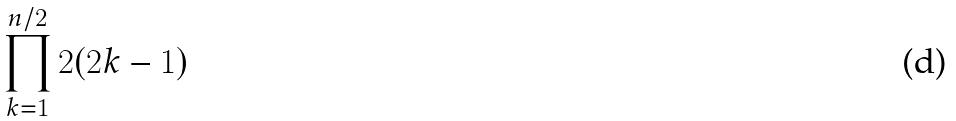<formula> <loc_0><loc_0><loc_500><loc_500>\prod _ { k = 1 } ^ { n / 2 } 2 ( 2 k - 1 )</formula> 